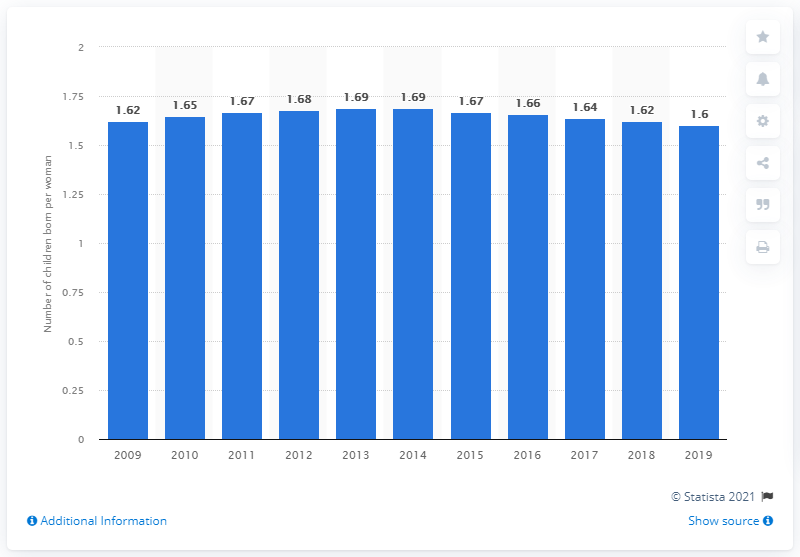Point out several critical features in this image. The fertility rate in Cuba was 1.6 children per woman in 2019. 